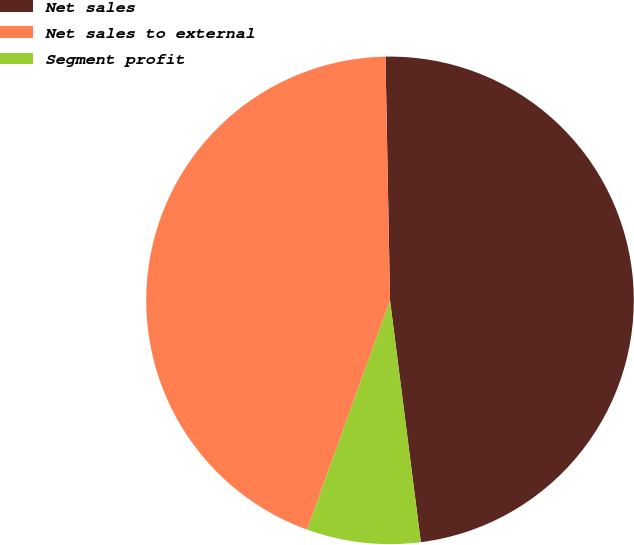Convert chart to OTSL. <chart><loc_0><loc_0><loc_500><loc_500><pie_chart><fcel>Net sales<fcel>Net sales to external<fcel>Segment profit<nl><fcel>48.28%<fcel>44.18%<fcel>7.54%<nl></chart> 